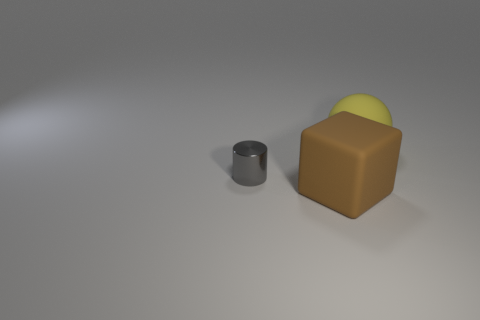Add 2 cubes. How many objects exist? 5 Subtract all spheres. How many objects are left? 2 Add 3 large rubber balls. How many large rubber balls exist? 4 Subtract 0 blue spheres. How many objects are left? 3 Subtract all gray metal cylinders. Subtract all brown things. How many objects are left? 1 Add 2 big things. How many big things are left? 4 